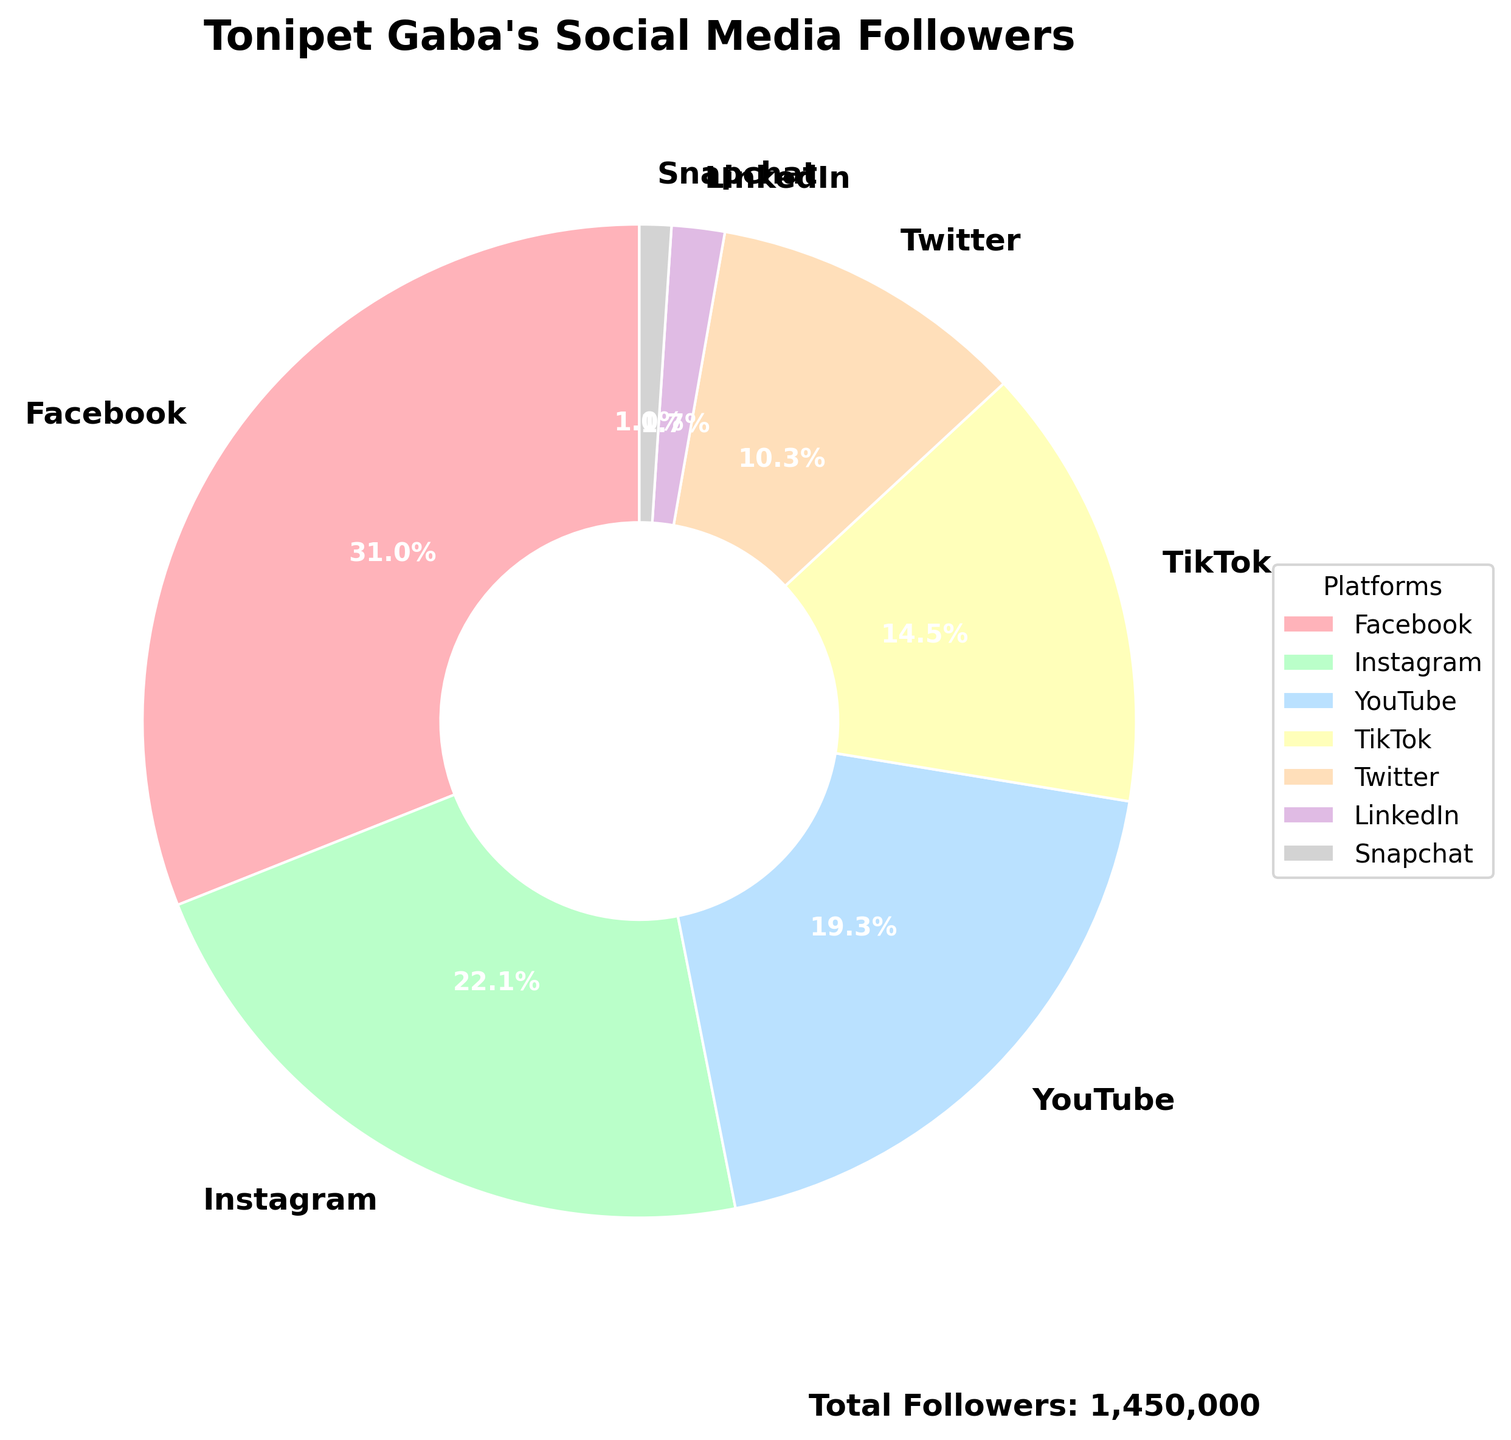What percentage of Tonipet Gaba's followers are on Instagram? The pie chart shows the proportion of followers on each platform. The segment for Instagram indicates 22.8%.
Answer: 22.8% Which platform has the fewest followers and what percentage does it make up? By looking at the pie chart, the smallest segment corresponds to Snapchat, which is shown to have 1.1% of the total followers.
Answer: Snapchat, 1.1% How many more followers does Facebook have compared to YouTube? Facebook has 450,000 followers, and YouTube has 280,000 followers. Subtracting these gives 450,000 - 280,000 = 170,000.
Answer: 170,000 What is the total number of followers across all platforms? The pie chart's annotation lists the total followers. Alternatively, summing all provided values: 450,000 (Facebook) + 320,000 (Instagram) + 280,000 (YouTube) + 210,000 (TikTok) + 150,000 (Twitter) + 25,000 (LinkedIn) + 15,000 (Snapchat) = 1,450,000.
Answer: 1,450,000 Compare the number of followers on TikTok and Twitter. Which platform has more followers and by how much? TikTok has 210,000 followers, whereas Twitter has 150,000. Subtracting these gives 210,000 - 150,000 = 60,000. TikTok has more followers by 60,000.
Answer: TikTok, 60,000 What is the combined percentage of followers on LinkedIn and Snapchat? LinkedIn has 1.7% and Snapchat has 1.0%, combining these two gives 1.7% + 1.0% = 2.7%.
Answer: 2.7% How many platforms have more than 150,000 followers? Referring to the data: Facebook (450,000), Instagram (320,000), and YouTube (280,000), and TikTok (210,000) all surpass 150,000 followers. There are 4 platforms.
Answer: 4 platforms What platform has the second most followers, and what is that number? After Facebook, which has the most followers, Instagram has the second most with 320,000 followers.
Answer: Instagram, 320,000 